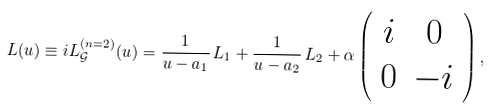Convert formula to latex. <formula><loc_0><loc_0><loc_500><loc_500>L ( u ) \equiv i L _ { \mathcal { G } } ^ { ( n = 2 ) } ( u ) = \frac { 1 } { u - a _ { 1 } } \, L _ { 1 } + \frac { 1 } { u - a _ { 2 } } \, L _ { 2 } + \alpha \left ( \begin{array} { c c } i & 0 \\ 0 & - i \end{array} \right ) ,</formula> 